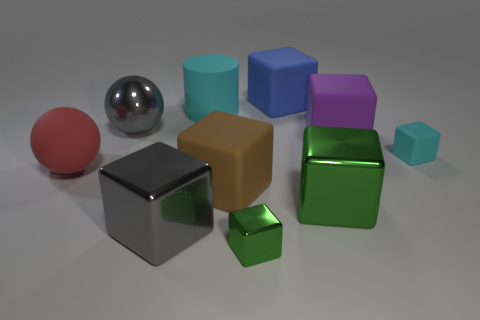Subtract 3 blocks. How many blocks are left? 4 Subtract all green blocks. How many blocks are left? 5 Subtract all tiny cyan cubes. How many cubes are left? 6 Subtract all brown cubes. Subtract all yellow cylinders. How many cubes are left? 6 Subtract all spheres. How many objects are left? 8 Subtract 0 brown balls. How many objects are left? 10 Subtract all purple matte cylinders. Subtract all large green objects. How many objects are left? 9 Add 5 large blue cubes. How many large blue cubes are left? 6 Add 5 large blue rubber spheres. How many large blue rubber spheres exist? 5 